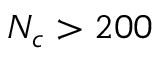<formula> <loc_0><loc_0><loc_500><loc_500>N _ { c } > 2 0 0</formula> 